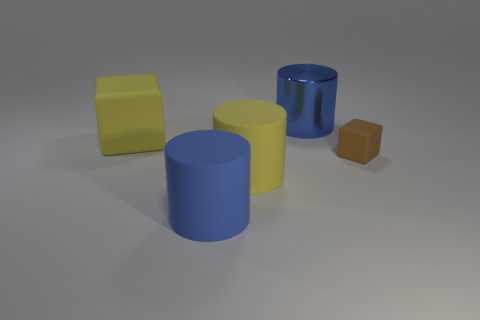Subtract all big matte cylinders. How many cylinders are left? 1 Add 3 blue cylinders. How many objects exist? 8 Subtract all blocks. How many objects are left? 3 Subtract 0 brown cylinders. How many objects are left? 5 Subtract all rubber objects. Subtract all big yellow matte cylinders. How many objects are left? 0 Add 5 brown cubes. How many brown cubes are left? 6 Add 3 tiny blue rubber objects. How many tiny blue rubber objects exist? 3 